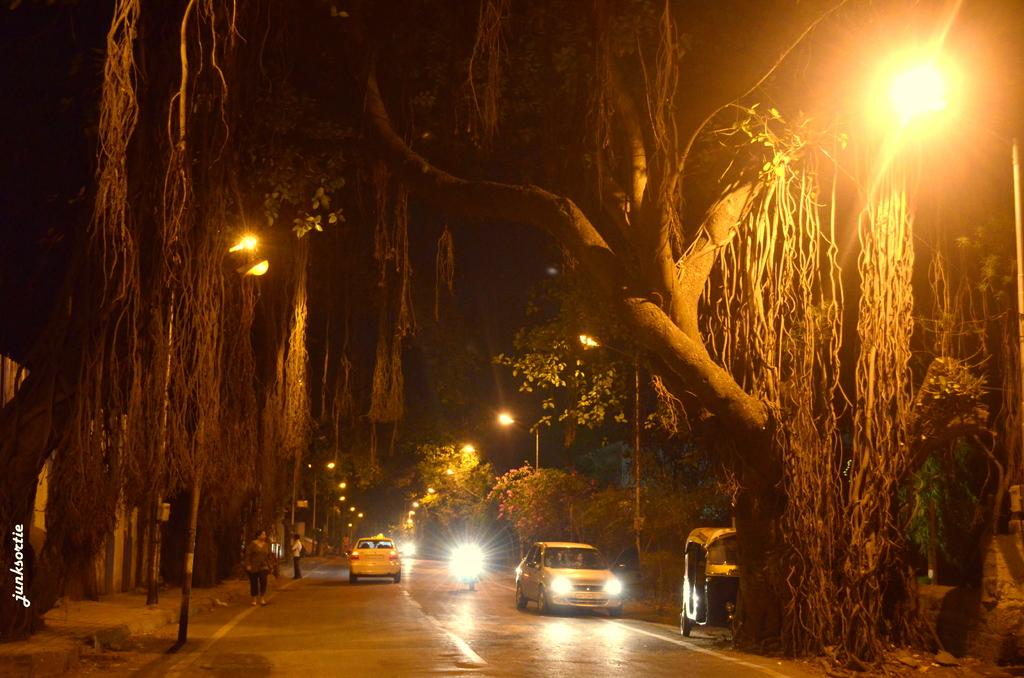What time of day is depicted in the image? The image is set at night time. What can be seen illuminated in the image? There are lights visible in the image. How many vehicles are present in the image? There is a car, another car on the right side of the image, and an auto (possibly a rickshawshaw or tuk-tuk) in the image. What type of sock is the driver of the car wearing in the image? There is no information about the driver's attire, including socks, in the image. What temperature is the hot beverage being consumed by the passengers in the image? There is no hot beverage or indication of temperature in the image. 